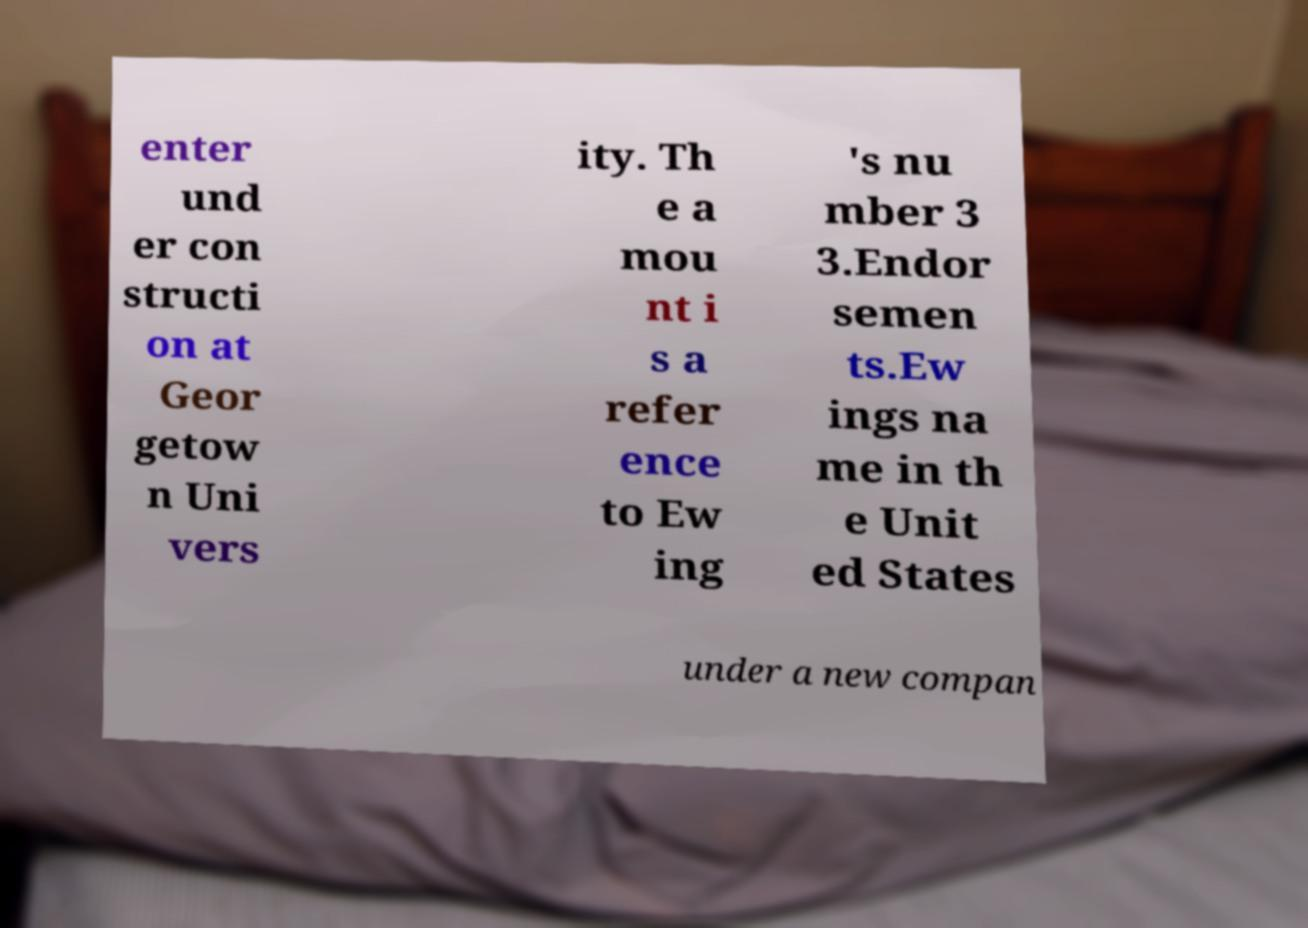I need the written content from this picture converted into text. Can you do that? enter und er con structi on at Geor getow n Uni vers ity. Th e a mou nt i s a refer ence to Ew ing 's nu mber 3 3.Endor semen ts.Ew ings na me in th e Unit ed States under a new compan 